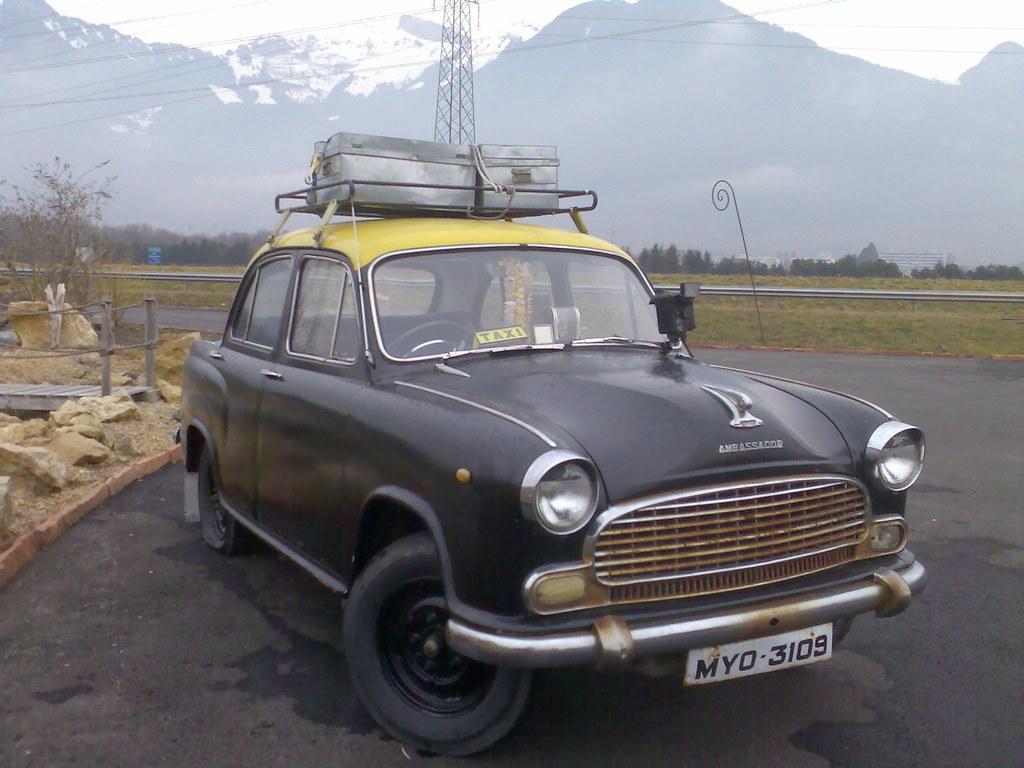Describe this image in one or two sentences. This is the picture of a car which is on the road and around there are some trees, plants, mountains, tower and some rocks around. 